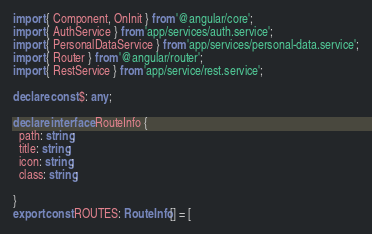Convert code to text. <code><loc_0><loc_0><loc_500><loc_500><_TypeScript_>import { Component, OnInit } from '@angular/core';
import { AuthService } from 'app/services/auth.service';
import { PersonalDataService } from 'app/services/personal-data.service';
import { Router } from '@angular/router';
import { RestService } from 'app/service/rest.service';

declare const $: any;

declare interface RouteInfo {
  path: string;
  title: string;
  icon: string;
  class: string;

}
export const ROUTES: RouteInfo[] = [</code> 